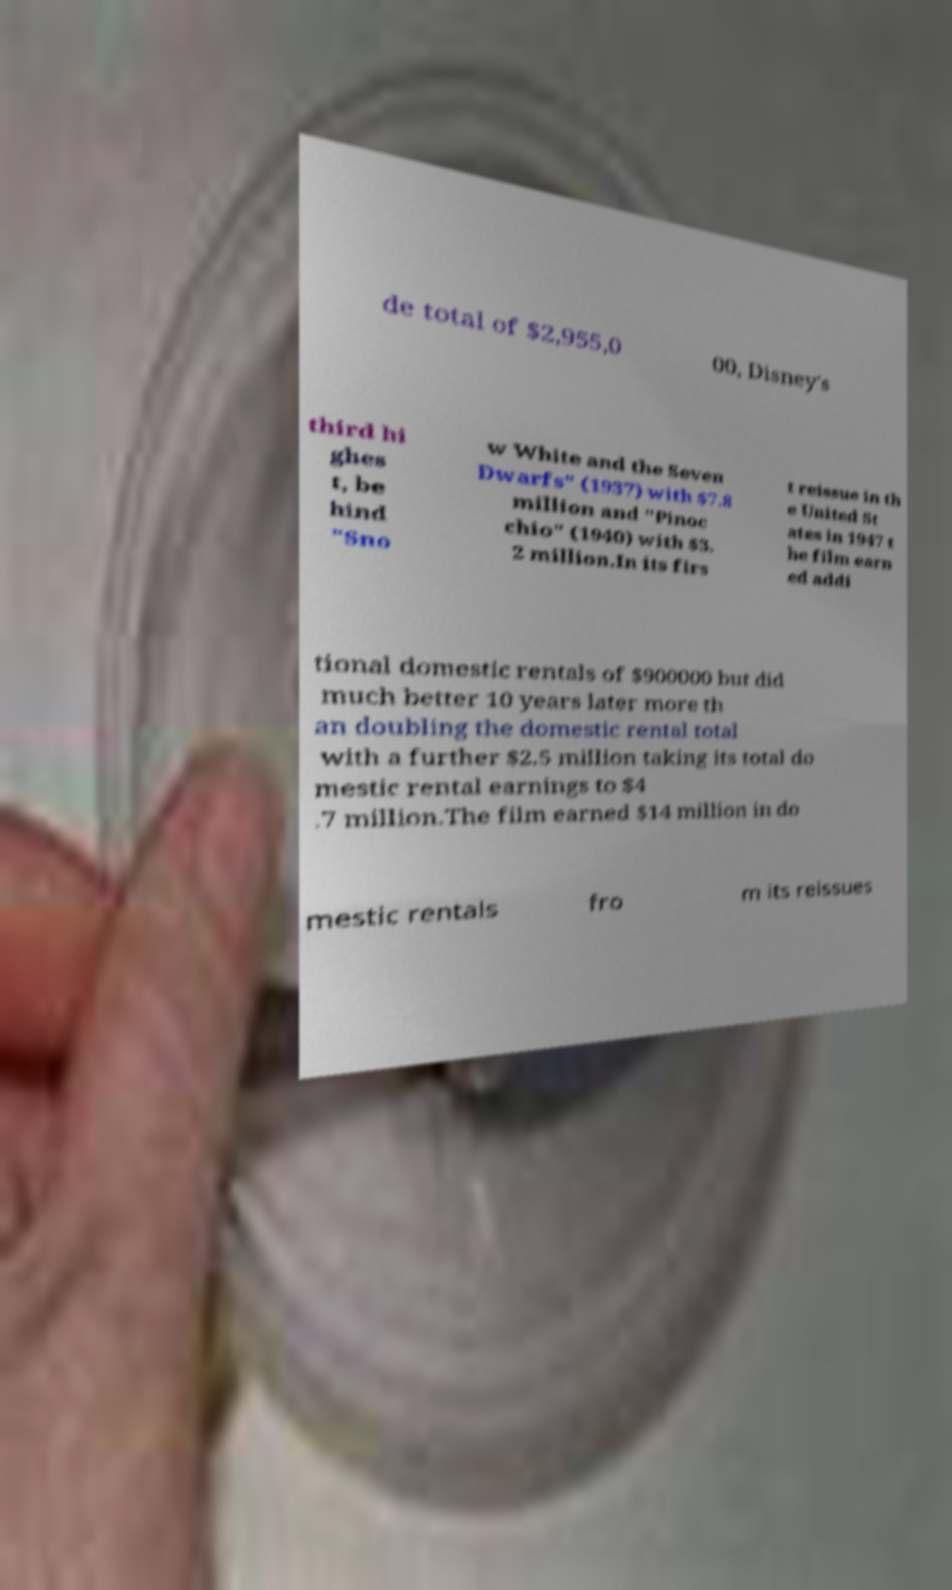Could you assist in decoding the text presented in this image and type it out clearly? de total of $2,955,0 00, Disney's third hi ghes t, be hind "Sno w White and the Seven Dwarfs" (1937) with $7.8 million and "Pinoc chio" (1940) with $3. 2 million.In its firs t reissue in th e United St ates in 1947 t he film earn ed addi tional domestic rentals of $900000 but did much better 10 years later more th an doubling the domestic rental total with a further $2.5 million taking its total do mestic rental earnings to $4 .7 million.The film earned $14 million in do mestic rentals fro m its reissues 